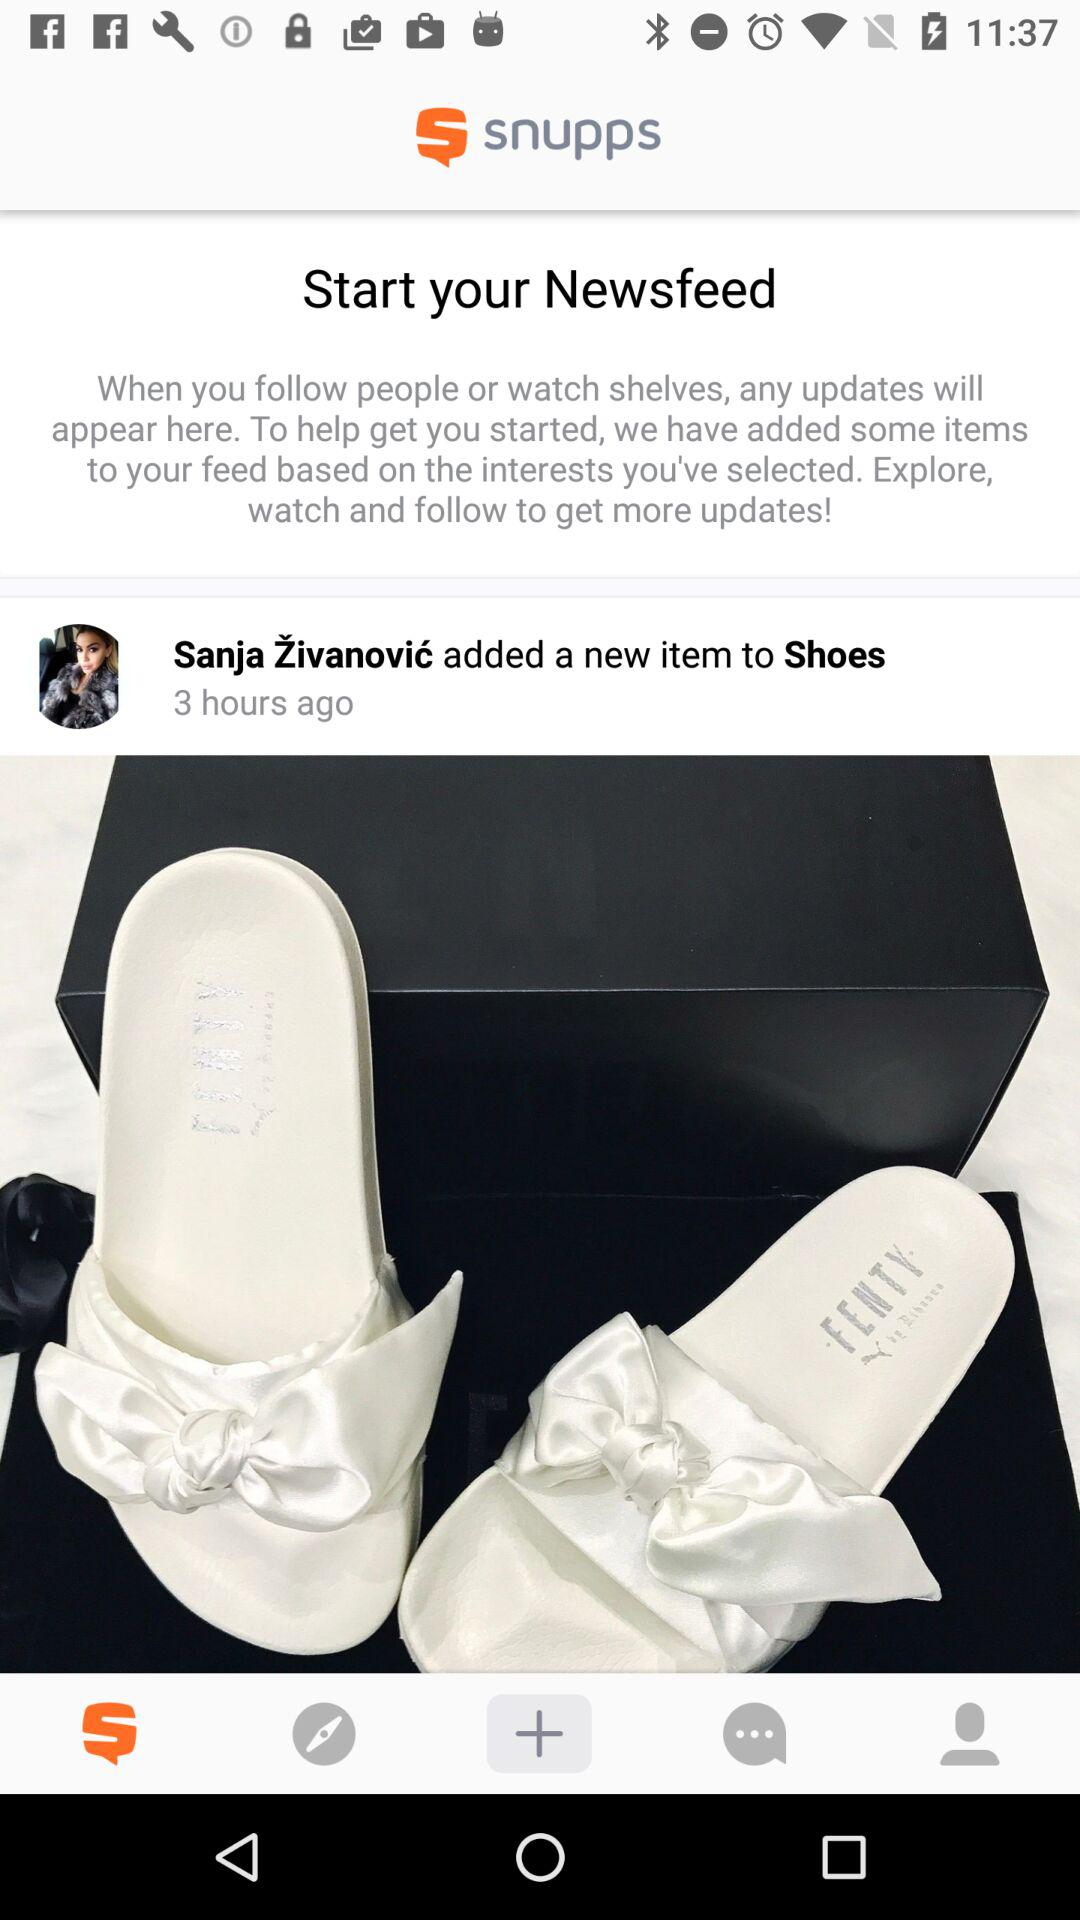What new item was added by Sanja Zivanovic?
When the provided information is insufficient, respond with <no answer>. <no answer> 